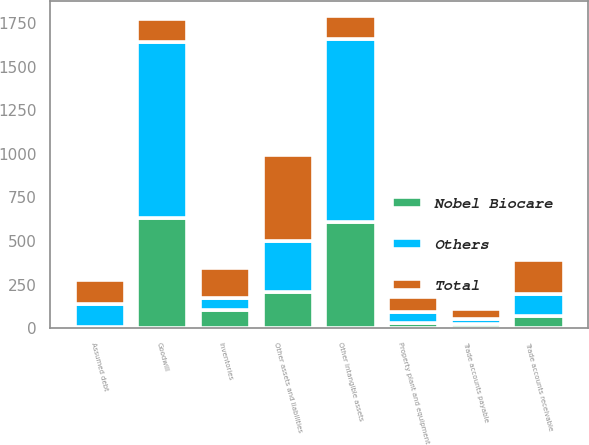Convert chart to OTSL. <chart><loc_0><loc_0><loc_500><loc_500><stacked_bar_chart><ecel><fcel>Trade accounts receivable<fcel>Inventories<fcel>Property plant and equipment<fcel>Goodwill<fcel>Other intangible assets<fcel>Trade accounts payable<fcel>Other assets and liabilities<fcel>Assumed debt<nl><fcel>Others<fcel>124.9<fcel>69<fcel>59.4<fcel>1013.6<fcel>1049.3<fcel>30.8<fcel>291<fcel>132.7<nl><fcel>Nobel Biocare<fcel>71.5<fcel>105<fcel>31.6<fcel>630<fcel>608.9<fcel>23.9<fcel>206.6<fcel>5.8<nl><fcel>Total<fcel>196.4<fcel>174<fcel>91<fcel>128.8<fcel>128.8<fcel>54.7<fcel>497.6<fcel>138.5<nl></chart> 